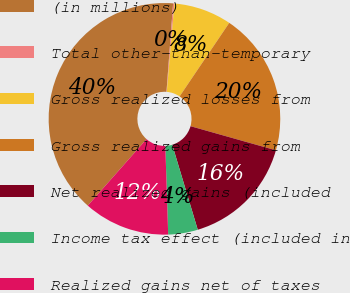<chart> <loc_0><loc_0><loc_500><loc_500><pie_chart><fcel>(in millions)<fcel>Total other-than-temporary<fcel>Gross realized losses from<fcel>Gross realized gains from<fcel>Net realized gains (included<fcel>Income tax effect (included in<fcel>Realized gains net of taxes<nl><fcel>39.68%<fcel>0.18%<fcel>8.08%<fcel>19.93%<fcel>15.98%<fcel>4.13%<fcel>12.03%<nl></chart> 